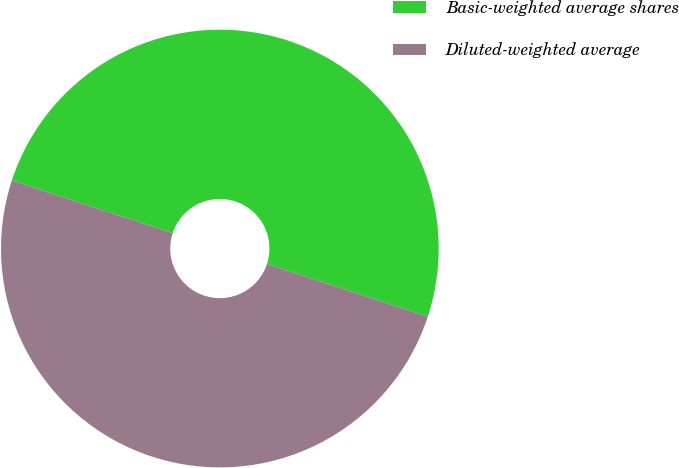<chart> <loc_0><loc_0><loc_500><loc_500><pie_chart><fcel>Basic-weighted average shares<fcel>Diluted-weighted average<nl><fcel>50.0%<fcel>50.0%<nl></chart> 